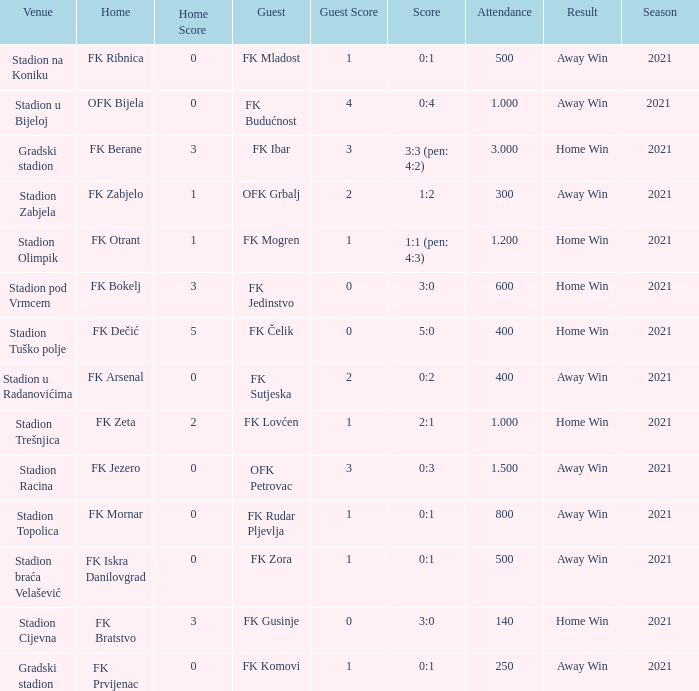What was the score for the game with FK Bratstvo as home team? 3:0. 